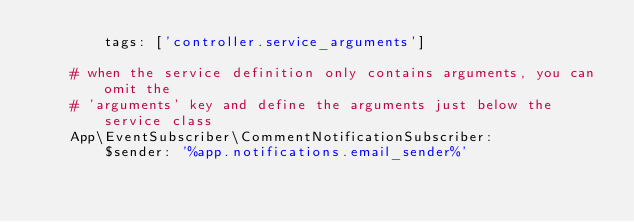Convert code to text. <code><loc_0><loc_0><loc_500><loc_500><_YAML_>        tags: ['controller.service_arguments']

    # when the service definition only contains arguments, you can omit the
    # 'arguments' key and define the arguments just below the service class
    App\EventSubscriber\CommentNotificationSubscriber:
        $sender: '%app.notifications.email_sender%'
</code> 